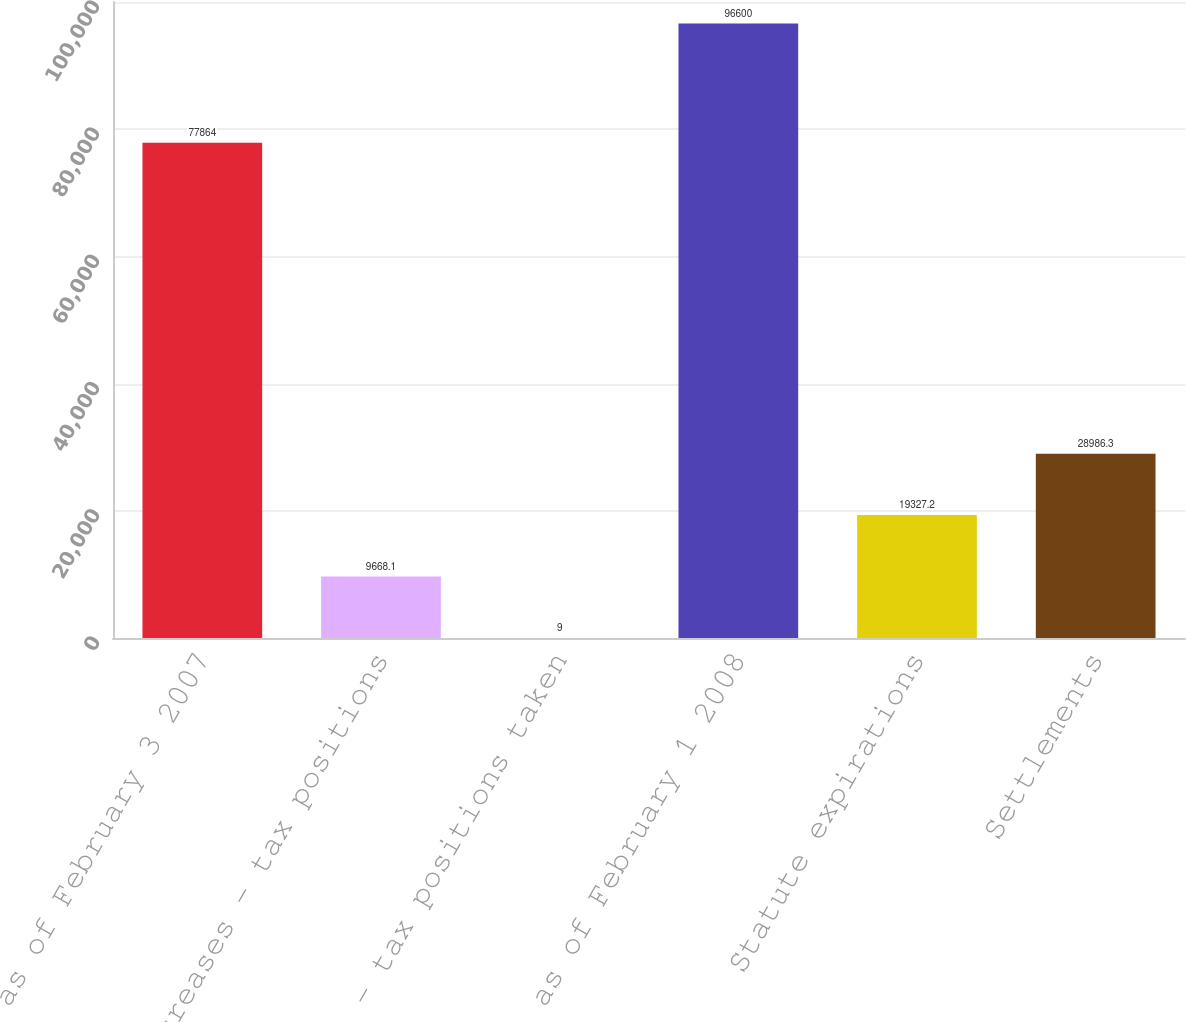<chart> <loc_0><loc_0><loc_500><loc_500><bar_chart><fcel>Balance as of February 3 2007<fcel>Increases - tax positions<fcel>Decrease - tax positions taken<fcel>Balance as of February 1 2008<fcel>Statute expirations<fcel>Settlements<nl><fcel>77864<fcel>9668.1<fcel>9<fcel>96600<fcel>19327.2<fcel>28986.3<nl></chart> 